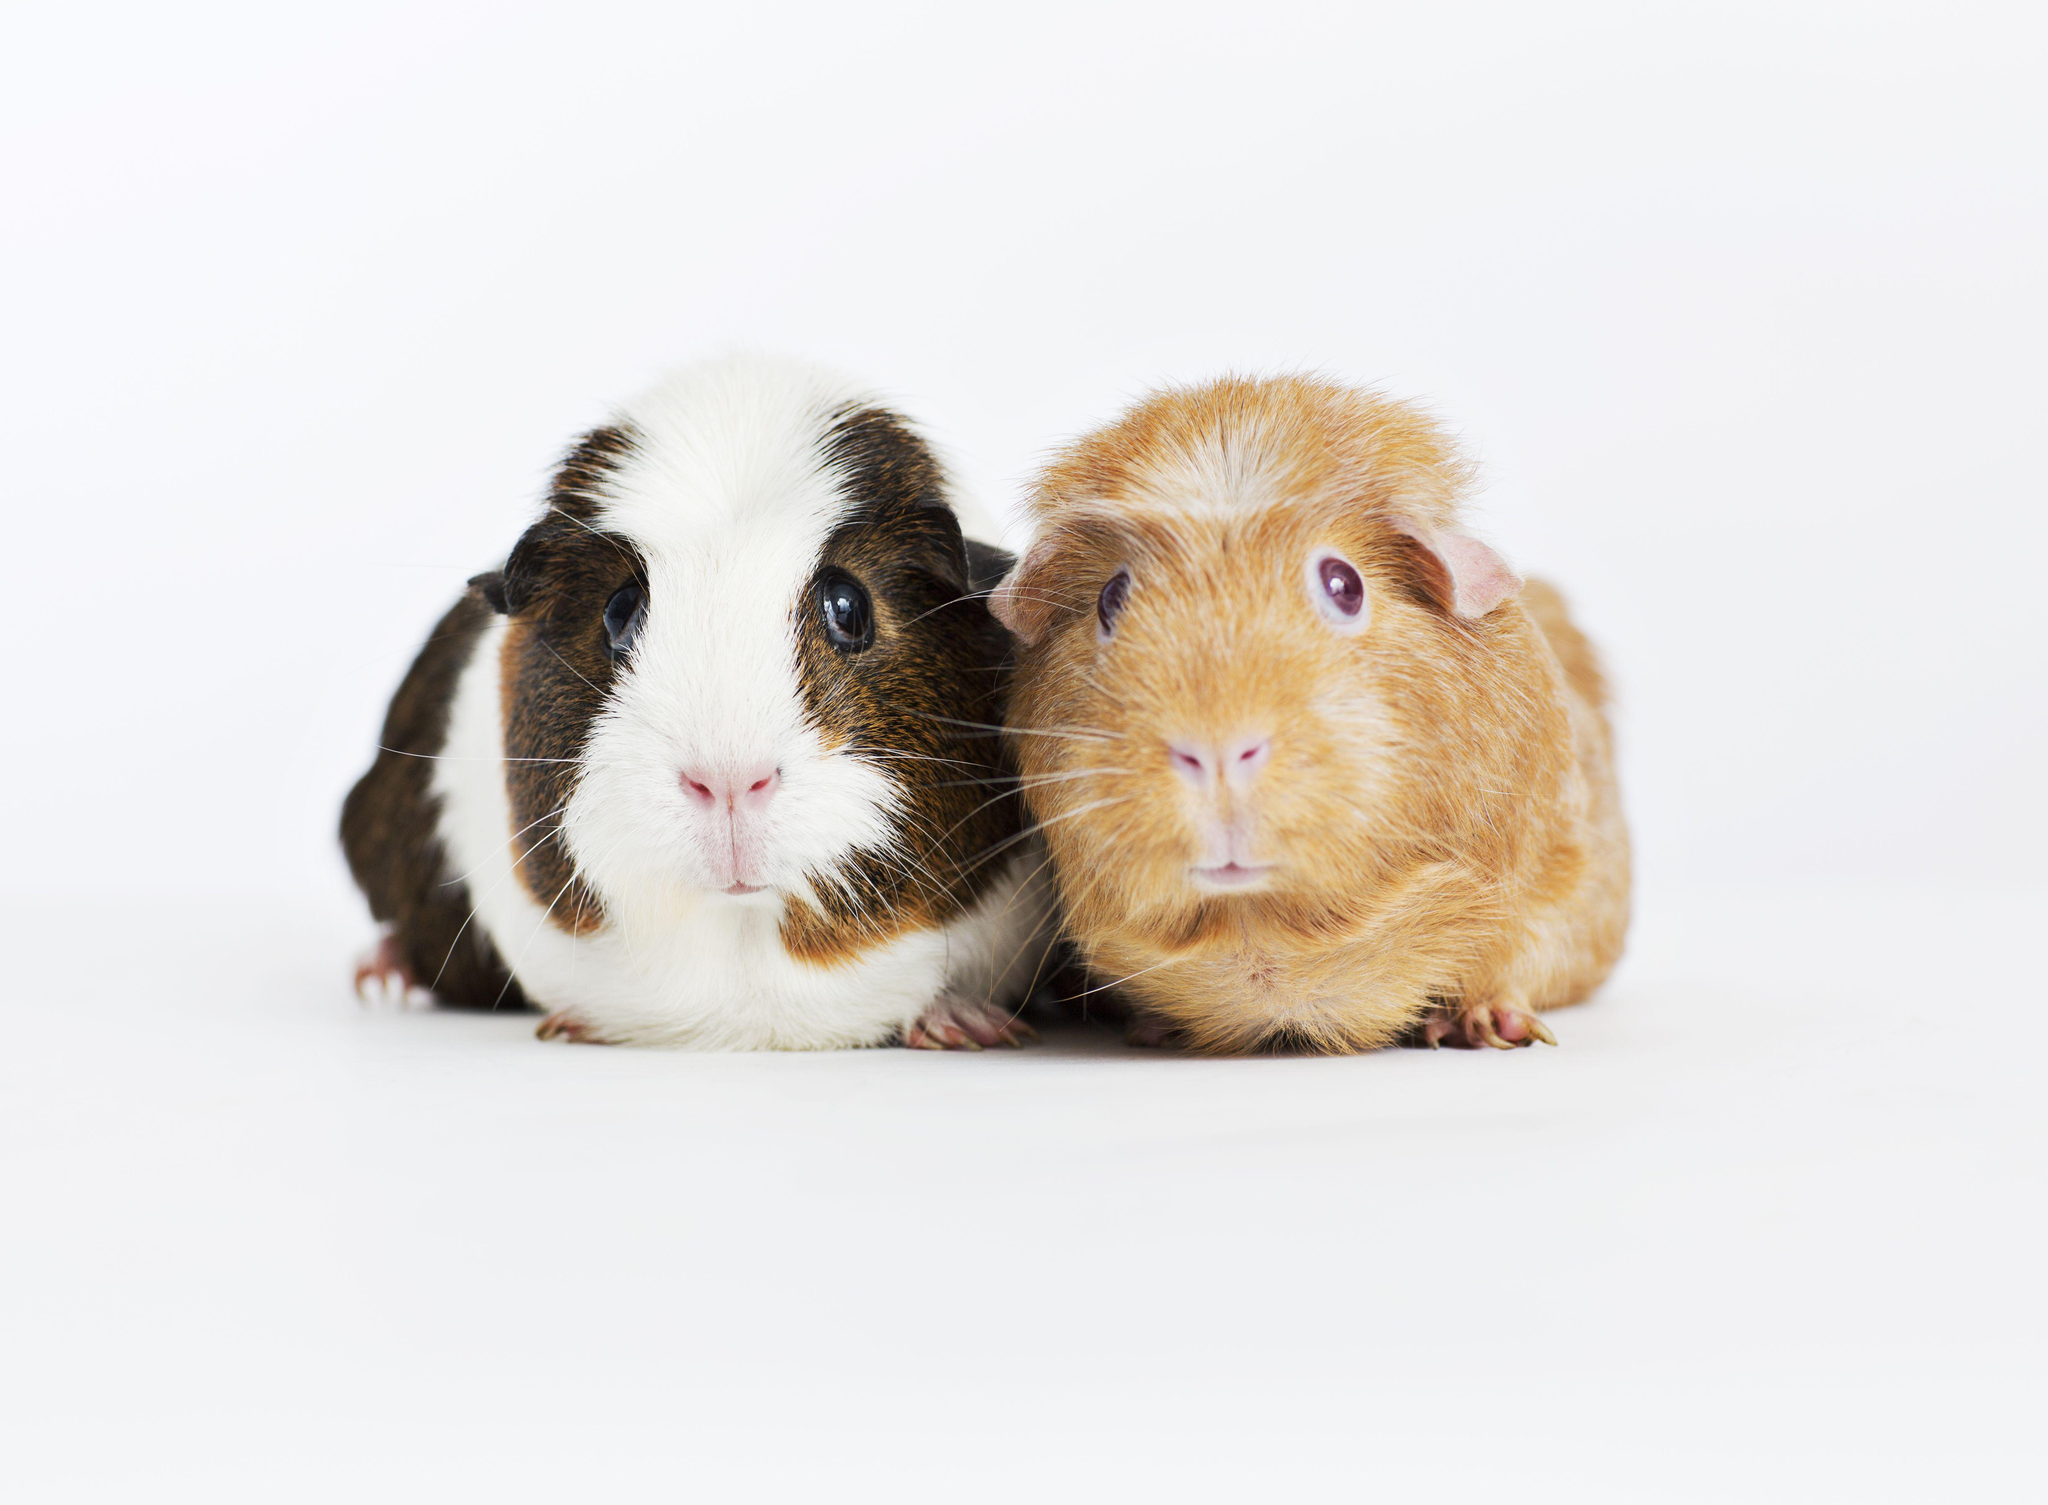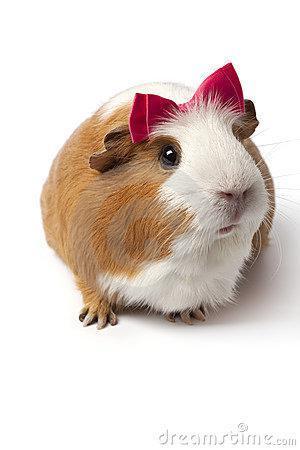The first image is the image on the left, the second image is the image on the right. Analyze the images presented: Is the assertion "A person is holding one of the animals." valid? Answer yes or no. No. 